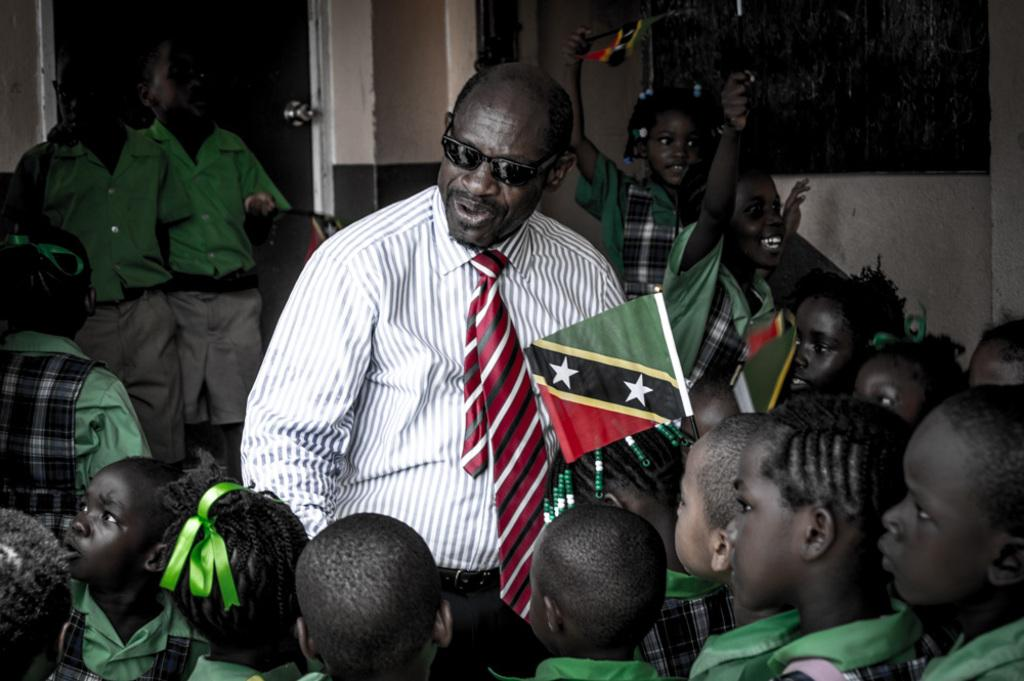How many kids are in the image? There are kids in the image, but the exact number is not specified. How are the kids arranged in the image? The kids are arranged from left to right in the image. What are some kids holding in the image? Some kids are holding flags in the image. Can you describe the man in the image? There is a man wearing goggles in the image. What is a feature of the door in the image? There is a door handle on the left side of the door in the image. What type of punishment is being administered to the kids in the image? There is no indication of punishment in the image; the kids are simply arranged from left to right and some are holding flags. How many minutes does it take for the truck to pass by in the image? There is no truck present in the image, so it is not possible to determine how many minutes it would take for a truck to pass by. 